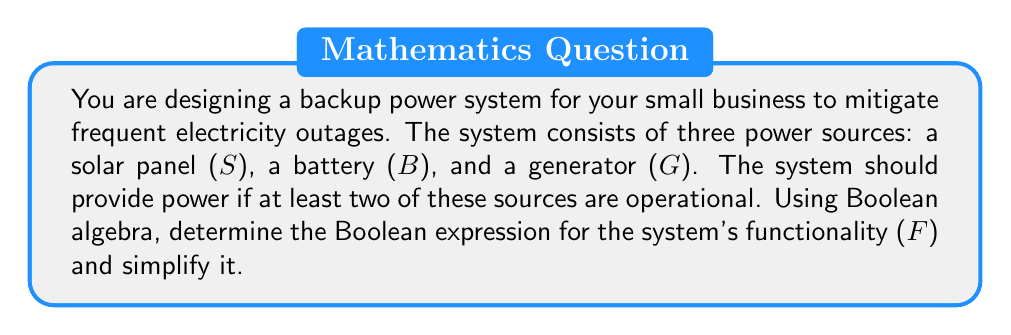Show me your answer to this math problem. Let's approach this step-by-step:

1) First, we need to define our variables:
   S: Solar panel is operational (1 if operational, 0 if not)
   B: Battery is operational (1 if operational, 0 if not)
   G: Generator is operational (1 if operational, 0 if not)
   F: System is functional (1 if functional, 0 if not)

2) The system is functional if at least two sources are operational. We can express this as:

   $$F = SB + SG + BG - SBG$$

   This expression includes all cases where two or more sources are operational.

3) To simplify this, let's use Boolean algebra laws:

   $$F = SB + SG + BG - SBG$$
   $$= SB + SG + BG + SBG$$ (Since $-SBG = +SBG$ in Boolean algebra)

4) Now, we can factor out S:

   $$F = S(B + G) + BG$$

5) This is already a simplified form, but we can verify it's correctness:
   - If S=1, B=1, G=0: F = 1(1+0) + 1*0 = 1
   - If S=1, B=0, G=1: F = 1(0+1) + 0*1 = 1
   - If S=0, B=1, G=1: F = 0(1+1) + 1*1 = 1
   - If S=1, B=1, G=1: F = 1(1+1) + 1*1 = 1
   - If S=0, B=0, G=1: F = 0(0+1) + 0*1 = 0

   This confirms our expression is correct and simplified.
Answer: $$F = S(B + G) + BG$$ 